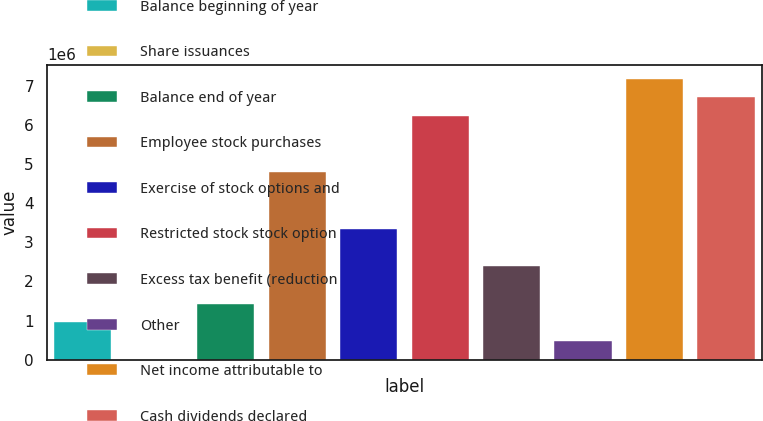Convert chart to OTSL. <chart><loc_0><loc_0><loc_500><loc_500><bar_chart><fcel>Balance beginning of year<fcel>Share issuances<fcel>Balance end of year<fcel>Employee stock purchases<fcel>Exercise of stock options and<fcel>Restricted stock stock option<fcel>Excess tax benefit (reduction<fcel>Other<fcel>Net income attributable to<fcel>Cash dividends declared<nl><fcel>957257<fcel>47<fcel>1.43586e+06<fcel>4.7861e+06<fcel>3.35028e+06<fcel>6.22191e+06<fcel>2.39307e+06<fcel>478652<fcel>7.17912e+06<fcel>6.70052e+06<nl></chart> 